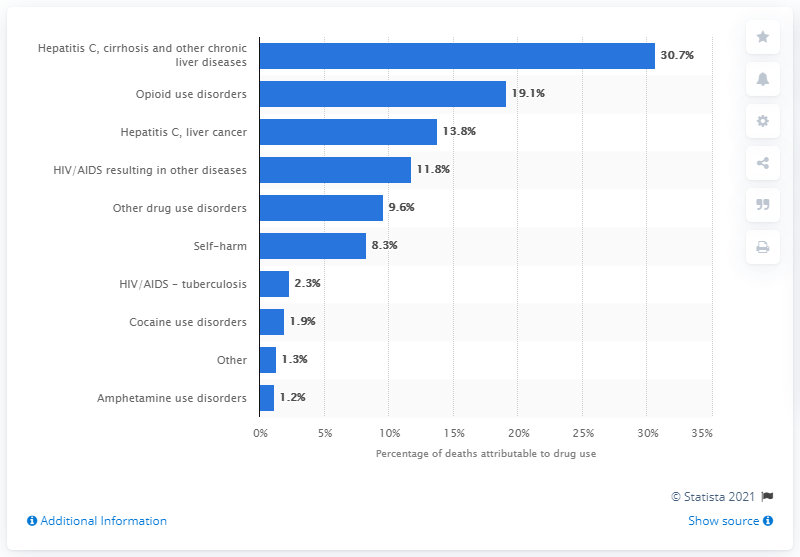Mention a couple of crucial points in this snapshot. A total of 30.7% of drug-related deaths were attributed to hepatitis C, cirrhosis, and other chronic liver diseases. 